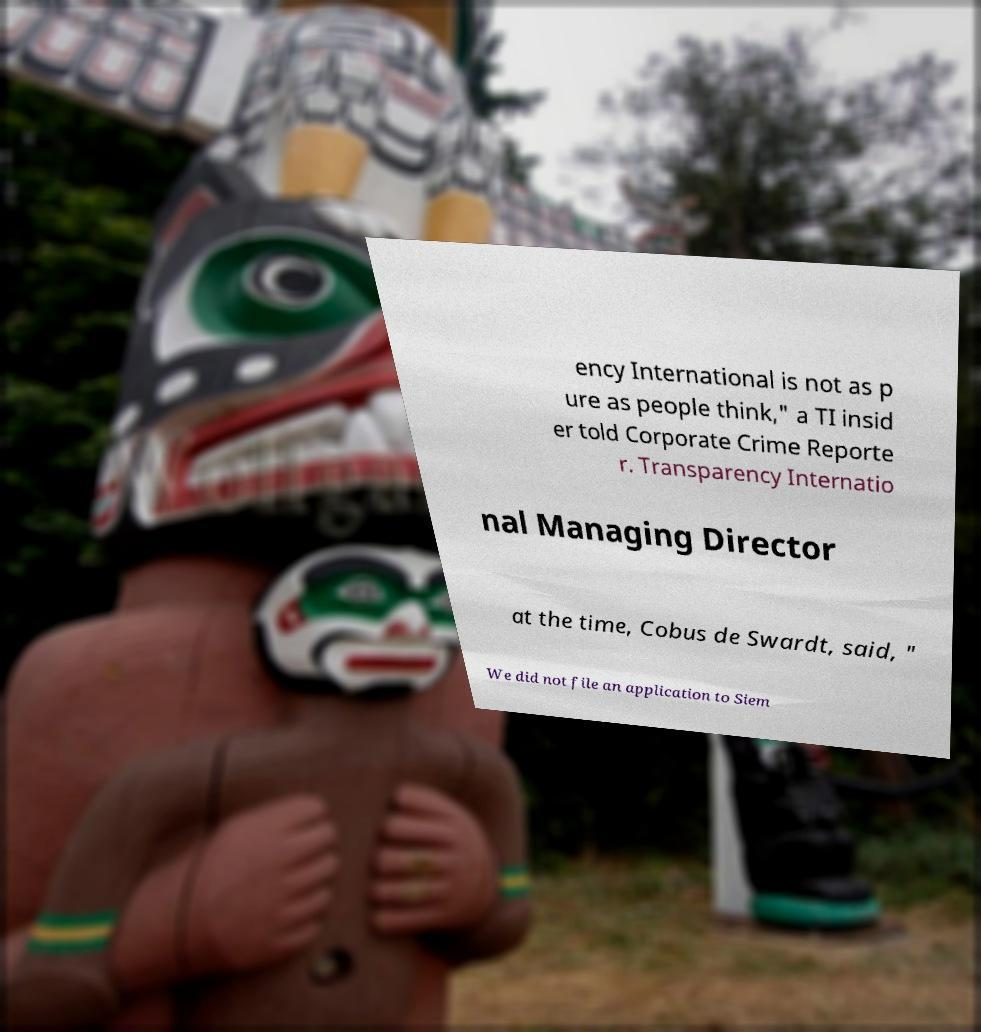Please identify and transcribe the text found in this image. ency International is not as p ure as people think," a TI insid er told Corporate Crime Reporte r. Transparency Internatio nal Managing Director at the time, Cobus de Swardt, said, " We did not file an application to Siem 